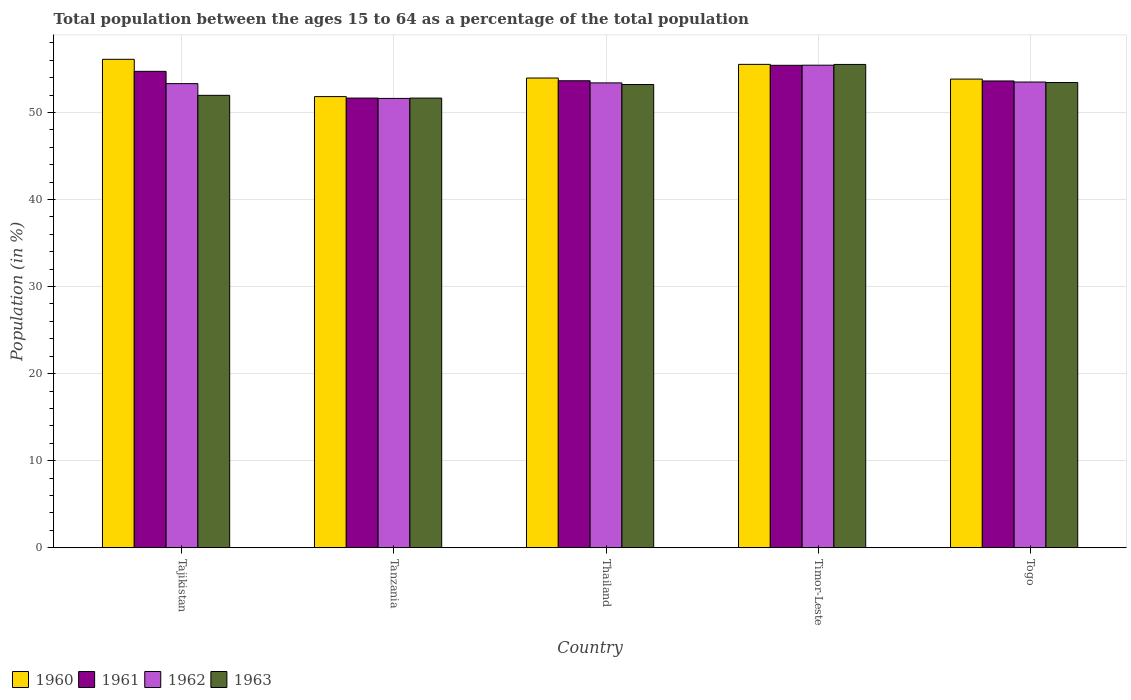How many bars are there on the 5th tick from the left?
Make the answer very short. 4. How many bars are there on the 3rd tick from the right?
Offer a terse response. 4. What is the label of the 2nd group of bars from the left?
Make the answer very short. Tanzania. What is the percentage of the population ages 15 to 64 in 1963 in Tanzania?
Your response must be concise. 51.65. Across all countries, what is the maximum percentage of the population ages 15 to 64 in 1961?
Your answer should be compact. 55.41. Across all countries, what is the minimum percentage of the population ages 15 to 64 in 1960?
Offer a very short reply. 51.82. In which country was the percentage of the population ages 15 to 64 in 1963 maximum?
Give a very brief answer. Timor-Leste. In which country was the percentage of the population ages 15 to 64 in 1962 minimum?
Keep it short and to the point. Tanzania. What is the total percentage of the population ages 15 to 64 in 1962 in the graph?
Give a very brief answer. 267.22. What is the difference between the percentage of the population ages 15 to 64 in 1961 in Tanzania and that in Togo?
Provide a short and direct response. -1.96. What is the difference between the percentage of the population ages 15 to 64 in 1960 in Thailand and the percentage of the population ages 15 to 64 in 1962 in Timor-Leste?
Provide a succinct answer. -1.47. What is the average percentage of the population ages 15 to 64 in 1962 per country?
Keep it short and to the point. 53.44. What is the difference between the percentage of the population ages 15 to 64 of/in 1960 and percentage of the population ages 15 to 64 of/in 1962 in Tanzania?
Keep it short and to the point. 0.21. What is the ratio of the percentage of the population ages 15 to 64 in 1960 in Tanzania to that in Thailand?
Make the answer very short. 0.96. Is the percentage of the population ages 15 to 64 in 1962 in Tajikistan less than that in Thailand?
Ensure brevity in your answer.  Yes. What is the difference between the highest and the second highest percentage of the population ages 15 to 64 in 1960?
Make the answer very short. 2.15. What is the difference between the highest and the lowest percentage of the population ages 15 to 64 in 1960?
Offer a very short reply. 4.28. Is the sum of the percentage of the population ages 15 to 64 in 1962 in Tajikistan and Tanzania greater than the maximum percentage of the population ages 15 to 64 in 1960 across all countries?
Your answer should be very brief. Yes. What does the 2nd bar from the right in Togo represents?
Ensure brevity in your answer.  1962. How many bars are there?
Give a very brief answer. 20. Are all the bars in the graph horizontal?
Ensure brevity in your answer.  No. How many countries are there in the graph?
Ensure brevity in your answer.  5. What is the difference between two consecutive major ticks on the Y-axis?
Keep it short and to the point. 10. Does the graph contain grids?
Give a very brief answer. Yes. How many legend labels are there?
Ensure brevity in your answer.  4. What is the title of the graph?
Make the answer very short. Total population between the ages 15 to 64 as a percentage of the total population. Does "1995" appear as one of the legend labels in the graph?
Ensure brevity in your answer.  No. What is the label or title of the Y-axis?
Provide a succinct answer. Population (in %). What is the Population (in %) in 1960 in Tajikistan?
Offer a very short reply. 56.1. What is the Population (in %) in 1961 in Tajikistan?
Ensure brevity in your answer.  54.72. What is the Population (in %) in 1962 in Tajikistan?
Give a very brief answer. 53.31. What is the Population (in %) of 1963 in Tajikistan?
Provide a succinct answer. 51.96. What is the Population (in %) in 1960 in Tanzania?
Make the answer very short. 51.82. What is the Population (in %) of 1961 in Tanzania?
Your answer should be compact. 51.65. What is the Population (in %) in 1962 in Tanzania?
Give a very brief answer. 51.61. What is the Population (in %) in 1963 in Tanzania?
Keep it short and to the point. 51.65. What is the Population (in %) of 1960 in Thailand?
Give a very brief answer. 53.95. What is the Population (in %) of 1961 in Thailand?
Offer a very short reply. 53.64. What is the Population (in %) of 1962 in Thailand?
Your response must be concise. 53.39. What is the Population (in %) of 1963 in Thailand?
Your response must be concise. 53.2. What is the Population (in %) in 1960 in Timor-Leste?
Give a very brief answer. 55.52. What is the Population (in %) of 1961 in Timor-Leste?
Make the answer very short. 55.41. What is the Population (in %) in 1962 in Timor-Leste?
Provide a short and direct response. 55.42. What is the Population (in %) of 1963 in Timor-Leste?
Offer a terse response. 55.51. What is the Population (in %) of 1960 in Togo?
Offer a very short reply. 53.83. What is the Population (in %) of 1961 in Togo?
Provide a short and direct response. 53.61. What is the Population (in %) of 1962 in Togo?
Keep it short and to the point. 53.49. What is the Population (in %) of 1963 in Togo?
Offer a terse response. 53.43. Across all countries, what is the maximum Population (in %) in 1960?
Provide a succinct answer. 56.1. Across all countries, what is the maximum Population (in %) of 1961?
Offer a very short reply. 55.41. Across all countries, what is the maximum Population (in %) in 1962?
Ensure brevity in your answer.  55.42. Across all countries, what is the maximum Population (in %) of 1963?
Offer a very short reply. 55.51. Across all countries, what is the minimum Population (in %) of 1960?
Your answer should be compact. 51.82. Across all countries, what is the minimum Population (in %) of 1961?
Provide a succinct answer. 51.65. Across all countries, what is the minimum Population (in %) of 1962?
Keep it short and to the point. 51.61. Across all countries, what is the minimum Population (in %) in 1963?
Make the answer very short. 51.65. What is the total Population (in %) of 1960 in the graph?
Keep it short and to the point. 271.21. What is the total Population (in %) of 1961 in the graph?
Offer a terse response. 269.03. What is the total Population (in %) of 1962 in the graph?
Give a very brief answer. 267.22. What is the total Population (in %) in 1963 in the graph?
Offer a very short reply. 265.76. What is the difference between the Population (in %) in 1960 in Tajikistan and that in Tanzania?
Your answer should be compact. 4.28. What is the difference between the Population (in %) in 1961 in Tajikistan and that in Tanzania?
Give a very brief answer. 3.07. What is the difference between the Population (in %) of 1962 in Tajikistan and that in Tanzania?
Provide a succinct answer. 1.7. What is the difference between the Population (in %) in 1963 in Tajikistan and that in Tanzania?
Provide a short and direct response. 0.32. What is the difference between the Population (in %) in 1960 in Tajikistan and that in Thailand?
Give a very brief answer. 2.15. What is the difference between the Population (in %) in 1961 in Tajikistan and that in Thailand?
Ensure brevity in your answer.  1.08. What is the difference between the Population (in %) in 1962 in Tajikistan and that in Thailand?
Offer a terse response. -0.09. What is the difference between the Population (in %) of 1963 in Tajikistan and that in Thailand?
Keep it short and to the point. -1.24. What is the difference between the Population (in %) in 1960 in Tajikistan and that in Timor-Leste?
Provide a succinct answer. 0.58. What is the difference between the Population (in %) of 1961 in Tajikistan and that in Timor-Leste?
Provide a succinct answer. -0.69. What is the difference between the Population (in %) in 1962 in Tajikistan and that in Timor-Leste?
Your answer should be compact. -2.12. What is the difference between the Population (in %) in 1963 in Tajikistan and that in Timor-Leste?
Ensure brevity in your answer.  -3.55. What is the difference between the Population (in %) in 1960 in Tajikistan and that in Togo?
Provide a succinct answer. 2.27. What is the difference between the Population (in %) in 1961 in Tajikistan and that in Togo?
Your answer should be very brief. 1.11. What is the difference between the Population (in %) of 1962 in Tajikistan and that in Togo?
Make the answer very short. -0.19. What is the difference between the Population (in %) in 1963 in Tajikistan and that in Togo?
Provide a short and direct response. -1.47. What is the difference between the Population (in %) of 1960 in Tanzania and that in Thailand?
Give a very brief answer. -2.13. What is the difference between the Population (in %) of 1961 in Tanzania and that in Thailand?
Offer a terse response. -1.99. What is the difference between the Population (in %) in 1962 in Tanzania and that in Thailand?
Ensure brevity in your answer.  -1.78. What is the difference between the Population (in %) of 1963 in Tanzania and that in Thailand?
Provide a short and direct response. -1.56. What is the difference between the Population (in %) in 1960 in Tanzania and that in Timor-Leste?
Give a very brief answer. -3.7. What is the difference between the Population (in %) of 1961 in Tanzania and that in Timor-Leste?
Keep it short and to the point. -3.76. What is the difference between the Population (in %) of 1962 in Tanzania and that in Timor-Leste?
Your response must be concise. -3.81. What is the difference between the Population (in %) of 1963 in Tanzania and that in Timor-Leste?
Your answer should be compact. -3.87. What is the difference between the Population (in %) of 1960 in Tanzania and that in Togo?
Your answer should be compact. -2.01. What is the difference between the Population (in %) of 1961 in Tanzania and that in Togo?
Your answer should be very brief. -1.96. What is the difference between the Population (in %) of 1962 in Tanzania and that in Togo?
Your answer should be very brief. -1.88. What is the difference between the Population (in %) of 1963 in Tanzania and that in Togo?
Give a very brief answer. -1.79. What is the difference between the Population (in %) in 1960 in Thailand and that in Timor-Leste?
Make the answer very short. -1.57. What is the difference between the Population (in %) of 1961 in Thailand and that in Timor-Leste?
Your answer should be very brief. -1.77. What is the difference between the Population (in %) in 1962 in Thailand and that in Timor-Leste?
Make the answer very short. -2.03. What is the difference between the Population (in %) of 1963 in Thailand and that in Timor-Leste?
Provide a succinct answer. -2.31. What is the difference between the Population (in %) in 1960 in Thailand and that in Togo?
Make the answer very short. 0.12. What is the difference between the Population (in %) of 1961 in Thailand and that in Togo?
Provide a short and direct response. 0.02. What is the difference between the Population (in %) in 1962 in Thailand and that in Togo?
Your answer should be compact. -0.1. What is the difference between the Population (in %) in 1963 in Thailand and that in Togo?
Offer a very short reply. -0.23. What is the difference between the Population (in %) in 1960 in Timor-Leste and that in Togo?
Your answer should be very brief. 1.69. What is the difference between the Population (in %) of 1961 in Timor-Leste and that in Togo?
Your answer should be compact. 1.8. What is the difference between the Population (in %) in 1962 in Timor-Leste and that in Togo?
Give a very brief answer. 1.93. What is the difference between the Population (in %) in 1963 in Timor-Leste and that in Togo?
Keep it short and to the point. 2.08. What is the difference between the Population (in %) in 1960 in Tajikistan and the Population (in %) in 1961 in Tanzania?
Give a very brief answer. 4.45. What is the difference between the Population (in %) in 1960 in Tajikistan and the Population (in %) in 1962 in Tanzania?
Your answer should be very brief. 4.49. What is the difference between the Population (in %) in 1960 in Tajikistan and the Population (in %) in 1963 in Tanzania?
Make the answer very short. 4.46. What is the difference between the Population (in %) of 1961 in Tajikistan and the Population (in %) of 1962 in Tanzania?
Keep it short and to the point. 3.11. What is the difference between the Population (in %) of 1961 in Tajikistan and the Population (in %) of 1963 in Tanzania?
Offer a very short reply. 3.07. What is the difference between the Population (in %) of 1962 in Tajikistan and the Population (in %) of 1963 in Tanzania?
Give a very brief answer. 1.66. What is the difference between the Population (in %) in 1960 in Tajikistan and the Population (in %) in 1961 in Thailand?
Your response must be concise. 2.47. What is the difference between the Population (in %) of 1960 in Tajikistan and the Population (in %) of 1962 in Thailand?
Provide a succinct answer. 2.71. What is the difference between the Population (in %) of 1960 in Tajikistan and the Population (in %) of 1963 in Thailand?
Your response must be concise. 2.9. What is the difference between the Population (in %) in 1961 in Tajikistan and the Population (in %) in 1962 in Thailand?
Your answer should be compact. 1.33. What is the difference between the Population (in %) of 1961 in Tajikistan and the Population (in %) of 1963 in Thailand?
Give a very brief answer. 1.51. What is the difference between the Population (in %) of 1962 in Tajikistan and the Population (in %) of 1963 in Thailand?
Provide a short and direct response. 0.1. What is the difference between the Population (in %) of 1960 in Tajikistan and the Population (in %) of 1961 in Timor-Leste?
Ensure brevity in your answer.  0.69. What is the difference between the Population (in %) in 1960 in Tajikistan and the Population (in %) in 1962 in Timor-Leste?
Make the answer very short. 0.68. What is the difference between the Population (in %) of 1960 in Tajikistan and the Population (in %) of 1963 in Timor-Leste?
Provide a succinct answer. 0.59. What is the difference between the Population (in %) in 1961 in Tajikistan and the Population (in %) in 1962 in Timor-Leste?
Provide a short and direct response. -0.71. What is the difference between the Population (in %) in 1961 in Tajikistan and the Population (in %) in 1963 in Timor-Leste?
Your answer should be compact. -0.79. What is the difference between the Population (in %) in 1962 in Tajikistan and the Population (in %) in 1963 in Timor-Leste?
Your answer should be very brief. -2.21. What is the difference between the Population (in %) of 1960 in Tajikistan and the Population (in %) of 1961 in Togo?
Ensure brevity in your answer.  2.49. What is the difference between the Population (in %) of 1960 in Tajikistan and the Population (in %) of 1962 in Togo?
Offer a terse response. 2.61. What is the difference between the Population (in %) in 1960 in Tajikistan and the Population (in %) in 1963 in Togo?
Offer a terse response. 2.67. What is the difference between the Population (in %) in 1961 in Tajikistan and the Population (in %) in 1962 in Togo?
Provide a short and direct response. 1.23. What is the difference between the Population (in %) of 1961 in Tajikistan and the Population (in %) of 1963 in Togo?
Keep it short and to the point. 1.28. What is the difference between the Population (in %) in 1962 in Tajikistan and the Population (in %) in 1963 in Togo?
Keep it short and to the point. -0.13. What is the difference between the Population (in %) of 1960 in Tanzania and the Population (in %) of 1961 in Thailand?
Your answer should be very brief. -1.82. What is the difference between the Population (in %) of 1960 in Tanzania and the Population (in %) of 1962 in Thailand?
Offer a terse response. -1.58. What is the difference between the Population (in %) in 1960 in Tanzania and the Population (in %) in 1963 in Thailand?
Offer a terse response. -1.39. What is the difference between the Population (in %) of 1961 in Tanzania and the Population (in %) of 1962 in Thailand?
Your response must be concise. -1.74. What is the difference between the Population (in %) of 1961 in Tanzania and the Population (in %) of 1963 in Thailand?
Give a very brief answer. -1.56. What is the difference between the Population (in %) of 1962 in Tanzania and the Population (in %) of 1963 in Thailand?
Your response must be concise. -1.59. What is the difference between the Population (in %) of 1960 in Tanzania and the Population (in %) of 1961 in Timor-Leste?
Your answer should be compact. -3.59. What is the difference between the Population (in %) of 1960 in Tanzania and the Population (in %) of 1962 in Timor-Leste?
Give a very brief answer. -3.61. What is the difference between the Population (in %) in 1960 in Tanzania and the Population (in %) in 1963 in Timor-Leste?
Make the answer very short. -3.7. What is the difference between the Population (in %) in 1961 in Tanzania and the Population (in %) in 1962 in Timor-Leste?
Your response must be concise. -3.78. What is the difference between the Population (in %) in 1961 in Tanzania and the Population (in %) in 1963 in Timor-Leste?
Your response must be concise. -3.86. What is the difference between the Population (in %) in 1962 in Tanzania and the Population (in %) in 1963 in Timor-Leste?
Your answer should be very brief. -3.9. What is the difference between the Population (in %) of 1960 in Tanzania and the Population (in %) of 1961 in Togo?
Provide a short and direct response. -1.8. What is the difference between the Population (in %) in 1960 in Tanzania and the Population (in %) in 1962 in Togo?
Your response must be concise. -1.68. What is the difference between the Population (in %) of 1960 in Tanzania and the Population (in %) of 1963 in Togo?
Your answer should be very brief. -1.62. What is the difference between the Population (in %) in 1961 in Tanzania and the Population (in %) in 1962 in Togo?
Offer a very short reply. -1.84. What is the difference between the Population (in %) of 1961 in Tanzania and the Population (in %) of 1963 in Togo?
Make the answer very short. -1.79. What is the difference between the Population (in %) in 1962 in Tanzania and the Population (in %) in 1963 in Togo?
Keep it short and to the point. -1.83. What is the difference between the Population (in %) of 1960 in Thailand and the Population (in %) of 1961 in Timor-Leste?
Give a very brief answer. -1.46. What is the difference between the Population (in %) in 1960 in Thailand and the Population (in %) in 1962 in Timor-Leste?
Make the answer very short. -1.47. What is the difference between the Population (in %) of 1960 in Thailand and the Population (in %) of 1963 in Timor-Leste?
Your response must be concise. -1.56. What is the difference between the Population (in %) of 1961 in Thailand and the Population (in %) of 1962 in Timor-Leste?
Offer a terse response. -1.79. What is the difference between the Population (in %) in 1961 in Thailand and the Population (in %) in 1963 in Timor-Leste?
Make the answer very short. -1.88. What is the difference between the Population (in %) of 1962 in Thailand and the Population (in %) of 1963 in Timor-Leste?
Your response must be concise. -2.12. What is the difference between the Population (in %) of 1960 in Thailand and the Population (in %) of 1961 in Togo?
Offer a terse response. 0.34. What is the difference between the Population (in %) in 1960 in Thailand and the Population (in %) in 1962 in Togo?
Give a very brief answer. 0.46. What is the difference between the Population (in %) in 1960 in Thailand and the Population (in %) in 1963 in Togo?
Your answer should be compact. 0.52. What is the difference between the Population (in %) of 1961 in Thailand and the Population (in %) of 1962 in Togo?
Provide a short and direct response. 0.14. What is the difference between the Population (in %) in 1961 in Thailand and the Population (in %) in 1963 in Togo?
Give a very brief answer. 0.2. What is the difference between the Population (in %) of 1962 in Thailand and the Population (in %) of 1963 in Togo?
Your answer should be very brief. -0.04. What is the difference between the Population (in %) of 1960 in Timor-Leste and the Population (in %) of 1961 in Togo?
Your answer should be very brief. 1.91. What is the difference between the Population (in %) in 1960 in Timor-Leste and the Population (in %) in 1962 in Togo?
Ensure brevity in your answer.  2.03. What is the difference between the Population (in %) in 1960 in Timor-Leste and the Population (in %) in 1963 in Togo?
Provide a succinct answer. 2.09. What is the difference between the Population (in %) in 1961 in Timor-Leste and the Population (in %) in 1962 in Togo?
Keep it short and to the point. 1.92. What is the difference between the Population (in %) in 1961 in Timor-Leste and the Population (in %) in 1963 in Togo?
Provide a succinct answer. 1.98. What is the difference between the Population (in %) in 1962 in Timor-Leste and the Population (in %) in 1963 in Togo?
Provide a short and direct response. 1.99. What is the average Population (in %) of 1960 per country?
Your response must be concise. 54.24. What is the average Population (in %) in 1961 per country?
Give a very brief answer. 53.81. What is the average Population (in %) in 1962 per country?
Give a very brief answer. 53.44. What is the average Population (in %) of 1963 per country?
Your response must be concise. 53.15. What is the difference between the Population (in %) in 1960 and Population (in %) in 1961 in Tajikistan?
Provide a succinct answer. 1.38. What is the difference between the Population (in %) in 1960 and Population (in %) in 1962 in Tajikistan?
Ensure brevity in your answer.  2.8. What is the difference between the Population (in %) in 1960 and Population (in %) in 1963 in Tajikistan?
Offer a very short reply. 4.14. What is the difference between the Population (in %) of 1961 and Population (in %) of 1962 in Tajikistan?
Your answer should be compact. 1.41. What is the difference between the Population (in %) in 1961 and Population (in %) in 1963 in Tajikistan?
Your answer should be compact. 2.76. What is the difference between the Population (in %) in 1962 and Population (in %) in 1963 in Tajikistan?
Provide a short and direct response. 1.34. What is the difference between the Population (in %) of 1960 and Population (in %) of 1961 in Tanzania?
Make the answer very short. 0.17. What is the difference between the Population (in %) of 1960 and Population (in %) of 1962 in Tanzania?
Offer a terse response. 0.21. What is the difference between the Population (in %) of 1960 and Population (in %) of 1963 in Tanzania?
Give a very brief answer. 0.17. What is the difference between the Population (in %) of 1961 and Population (in %) of 1962 in Tanzania?
Ensure brevity in your answer.  0.04. What is the difference between the Population (in %) in 1961 and Population (in %) in 1963 in Tanzania?
Make the answer very short. 0. What is the difference between the Population (in %) of 1962 and Population (in %) of 1963 in Tanzania?
Offer a very short reply. -0.04. What is the difference between the Population (in %) in 1960 and Population (in %) in 1961 in Thailand?
Offer a terse response. 0.31. What is the difference between the Population (in %) of 1960 and Population (in %) of 1962 in Thailand?
Your response must be concise. 0.56. What is the difference between the Population (in %) in 1960 and Population (in %) in 1963 in Thailand?
Keep it short and to the point. 0.75. What is the difference between the Population (in %) in 1961 and Population (in %) in 1962 in Thailand?
Your answer should be compact. 0.24. What is the difference between the Population (in %) of 1961 and Population (in %) of 1963 in Thailand?
Keep it short and to the point. 0.43. What is the difference between the Population (in %) of 1962 and Population (in %) of 1963 in Thailand?
Your answer should be compact. 0.19. What is the difference between the Population (in %) of 1960 and Population (in %) of 1961 in Timor-Leste?
Provide a succinct answer. 0.11. What is the difference between the Population (in %) in 1960 and Population (in %) in 1962 in Timor-Leste?
Keep it short and to the point. 0.1. What is the difference between the Population (in %) of 1960 and Population (in %) of 1963 in Timor-Leste?
Provide a succinct answer. 0.01. What is the difference between the Population (in %) of 1961 and Population (in %) of 1962 in Timor-Leste?
Give a very brief answer. -0.01. What is the difference between the Population (in %) in 1961 and Population (in %) in 1963 in Timor-Leste?
Your response must be concise. -0.1. What is the difference between the Population (in %) in 1962 and Population (in %) in 1963 in Timor-Leste?
Offer a very short reply. -0.09. What is the difference between the Population (in %) in 1960 and Population (in %) in 1961 in Togo?
Offer a very short reply. 0.21. What is the difference between the Population (in %) of 1960 and Population (in %) of 1962 in Togo?
Make the answer very short. 0.34. What is the difference between the Population (in %) in 1960 and Population (in %) in 1963 in Togo?
Your answer should be very brief. 0.39. What is the difference between the Population (in %) of 1961 and Population (in %) of 1962 in Togo?
Provide a succinct answer. 0.12. What is the difference between the Population (in %) of 1961 and Population (in %) of 1963 in Togo?
Provide a succinct answer. 0.18. What is the difference between the Population (in %) in 1962 and Population (in %) in 1963 in Togo?
Keep it short and to the point. 0.06. What is the ratio of the Population (in %) in 1960 in Tajikistan to that in Tanzania?
Give a very brief answer. 1.08. What is the ratio of the Population (in %) in 1961 in Tajikistan to that in Tanzania?
Offer a very short reply. 1.06. What is the ratio of the Population (in %) of 1962 in Tajikistan to that in Tanzania?
Offer a terse response. 1.03. What is the ratio of the Population (in %) of 1963 in Tajikistan to that in Tanzania?
Ensure brevity in your answer.  1.01. What is the ratio of the Population (in %) in 1960 in Tajikistan to that in Thailand?
Keep it short and to the point. 1.04. What is the ratio of the Population (in %) of 1961 in Tajikistan to that in Thailand?
Give a very brief answer. 1.02. What is the ratio of the Population (in %) of 1963 in Tajikistan to that in Thailand?
Your answer should be compact. 0.98. What is the ratio of the Population (in %) in 1960 in Tajikistan to that in Timor-Leste?
Your answer should be compact. 1.01. What is the ratio of the Population (in %) of 1961 in Tajikistan to that in Timor-Leste?
Make the answer very short. 0.99. What is the ratio of the Population (in %) in 1962 in Tajikistan to that in Timor-Leste?
Give a very brief answer. 0.96. What is the ratio of the Population (in %) of 1963 in Tajikistan to that in Timor-Leste?
Ensure brevity in your answer.  0.94. What is the ratio of the Population (in %) of 1960 in Tajikistan to that in Togo?
Offer a terse response. 1.04. What is the ratio of the Population (in %) of 1961 in Tajikistan to that in Togo?
Your answer should be very brief. 1.02. What is the ratio of the Population (in %) of 1962 in Tajikistan to that in Togo?
Your answer should be very brief. 1. What is the ratio of the Population (in %) in 1963 in Tajikistan to that in Togo?
Offer a terse response. 0.97. What is the ratio of the Population (in %) in 1960 in Tanzania to that in Thailand?
Your response must be concise. 0.96. What is the ratio of the Population (in %) in 1961 in Tanzania to that in Thailand?
Give a very brief answer. 0.96. What is the ratio of the Population (in %) of 1962 in Tanzania to that in Thailand?
Provide a succinct answer. 0.97. What is the ratio of the Population (in %) of 1963 in Tanzania to that in Thailand?
Your response must be concise. 0.97. What is the ratio of the Population (in %) in 1960 in Tanzania to that in Timor-Leste?
Your answer should be very brief. 0.93. What is the ratio of the Population (in %) in 1961 in Tanzania to that in Timor-Leste?
Give a very brief answer. 0.93. What is the ratio of the Population (in %) of 1962 in Tanzania to that in Timor-Leste?
Give a very brief answer. 0.93. What is the ratio of the Population (in %) of 1963 in Tanzania to that in Timor-Leste?
Provide a succinct answer. 0.93. What is the ratio of the Population (in %) in 1960 in Tanzania to that in Togo?
Your answer should be very brief. 0.96. What is the ratio of the Population (in %) in 1961 in Tanzania to that in Togo?
Offer a very short reply. 0.96. What is the ratio of the Population (in %) of 1962 in Tanzania to that in Togo?
Your answer should be compact. 0.96. What is the ratio of the Population (in %) in 1963 in Tanzania to that in Togo?
Offer a terse response. 0.97. What is the ratio of the Population (in %) of 1960 in Thailand to that in Timor-Leste?
Keep it short and to the point. 0.97. What is the ratio of the Population (in %) of 1961 in Thailand to that in Timor-Leste?
Ensure brevity in your answer.  0.97. What is the ratio of the Population (in %) in 1962 in Thailand to that in Timor-Leste?
Give a very brief answer. 0.96. What is the ratio of the Population (in %) of 1963 in Thailand to that in Timor-Leste?
Keep it short and to the point. 0.96. What is the ratio of the Population (in %) in 1962 in Thailand to that in Togo?
Offer a terse response. 1. What is the ratio of the Population (in %) of 1960 in Timor-Leste to that in Togo?
Provide a short and direct response. 1.03. What is the ratio of the Population (in %) of 1961 in Timor-Leste to that in Togo?
Offer a very short reply. 1.03. What is the ratio of the Population (in %) of 1962 in Timor-Leste to that in Togo?
Provide a short and direct response. 1.04. What is the ratio of the Population (in %) in 1963 in Timor-Leste to that in Togo?
Ensure brevity in your answer.  1.04. What is the difference between the highest and the second highest Population (in %) of 1960?
Your answer should be compact. 0.58. What is the difference between the highest and the second highest Population (in %) in 1961?
Ensure brevity in your answer.  0.69. What is the difference between the highest and the second highest Population (in %) in 1962?
Your answer should be compact. 1.93. What is the difference between the highest and the second highest Population (in %) in 1963?
Your answer should be very brief. 2.08. What is the difference between the highest and the lowest Population (in %) in 1960?
Provide a short and direct response. 4.28. What is the difference between the highest and the lowest Population (in %) in 1961?
Make the answer very short. 3.76. What is the difference between the highest and the lowest Population (in %) of 1962?
Your answer should be very brief. 3.81. What is the difference between the highest and the lowest Population (in %) of 1963?
Make the answer very short. 3.87. 